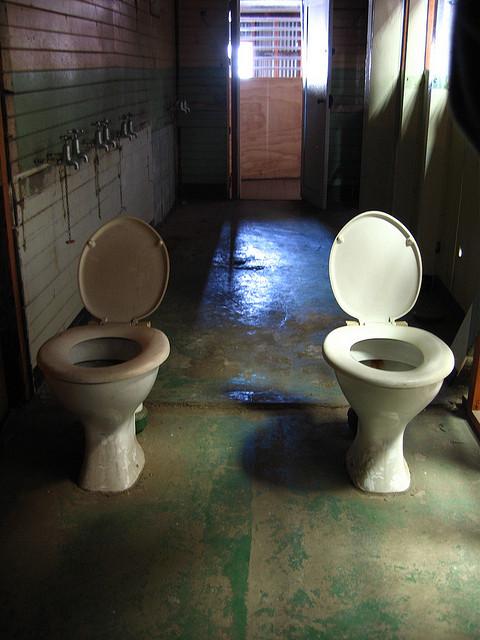How many toilets have the lid open?
Quick response, please. 2. Do any of these toilet work?
Write a very short answer. No. Are there any bathroom stalls?
Quick response, please. No. Does the area look like a comfortable place to take a shit?
Concise answer only. No. 